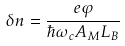<formula> <loc_0><loc_0><loc_500><loc_500>\delta n = \frac { e \varphi } { \hbar { \omega } _ { c } A _ { M } L _ { B } }</formula> 